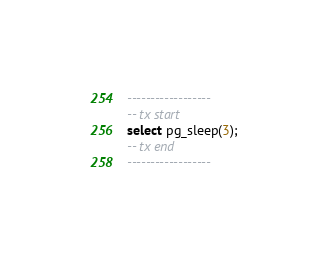Convert code to text. <code><loc_0><loc_0><loc_500><loc_500><_SQL_>------------------
-- tx start
select pg_sleep(3);
-- tx end
------------------</code> 